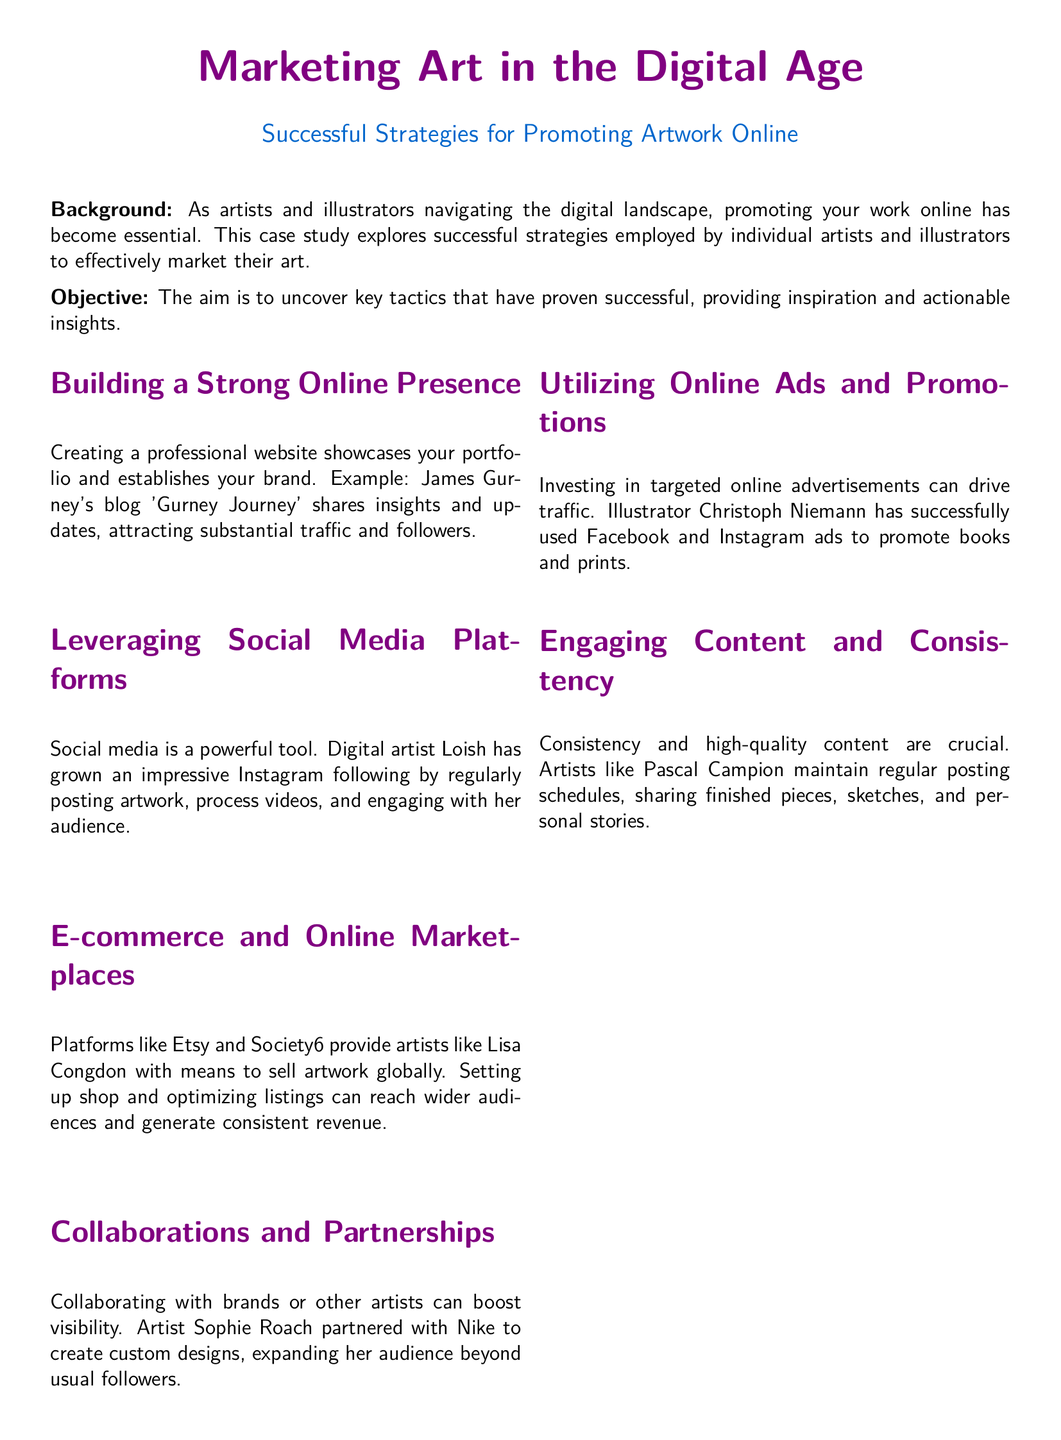What is the primary focus of the case study? The primary focus of the case study is exploring successful strategies employed by individual artists and illustrators to effectively market their art.
Answer: marketing strategies Who is the artist mentioned who has a blog named 'Gurney Journey'? The artist mentioned with the blog 'Gurney Journey' is James Gurney.
Answer: James Gurney Which social media platform did digital artist Loish use to grow her following? The social media platform used by digital artist Loish to grow her following is Instagram.
Answer: Instagram What online marketplace is mentioned that allows artists to sell artwork globally? The online marketplace mentioned that allows artists to sell artwork globally is Etsy.
Answer: Etsy Which artist partnered with Nike for custom designs? The artist who partnered with Nike is Sophie Roach.
Answer: Sophie Roach Which type of content is highlighted as crucial for online marketing? Engaging content and consistency are highlighted as crucial for online marketing.
Answer: Engaging content What is the call to action at the end of the case study? The call to action is to experiment with the approaches and share experiences with peers.
Answer: Experiment and share experiences How does Christoph Niemann promote his work? Christoph Niemann promotes his work by using Facebook and Instagram ads.
Answer: Online ads What is emphasized as important for maintaining an online presence? Consistency and high-quality content are emphasized as important for maintaining an online presence.
Answer: Consistency and quality content What is the concluding message of the case study? The concluding message is that incorporating these strategies can enhance online presence and increase sales and recognition.
Answer: Enhance online presence 